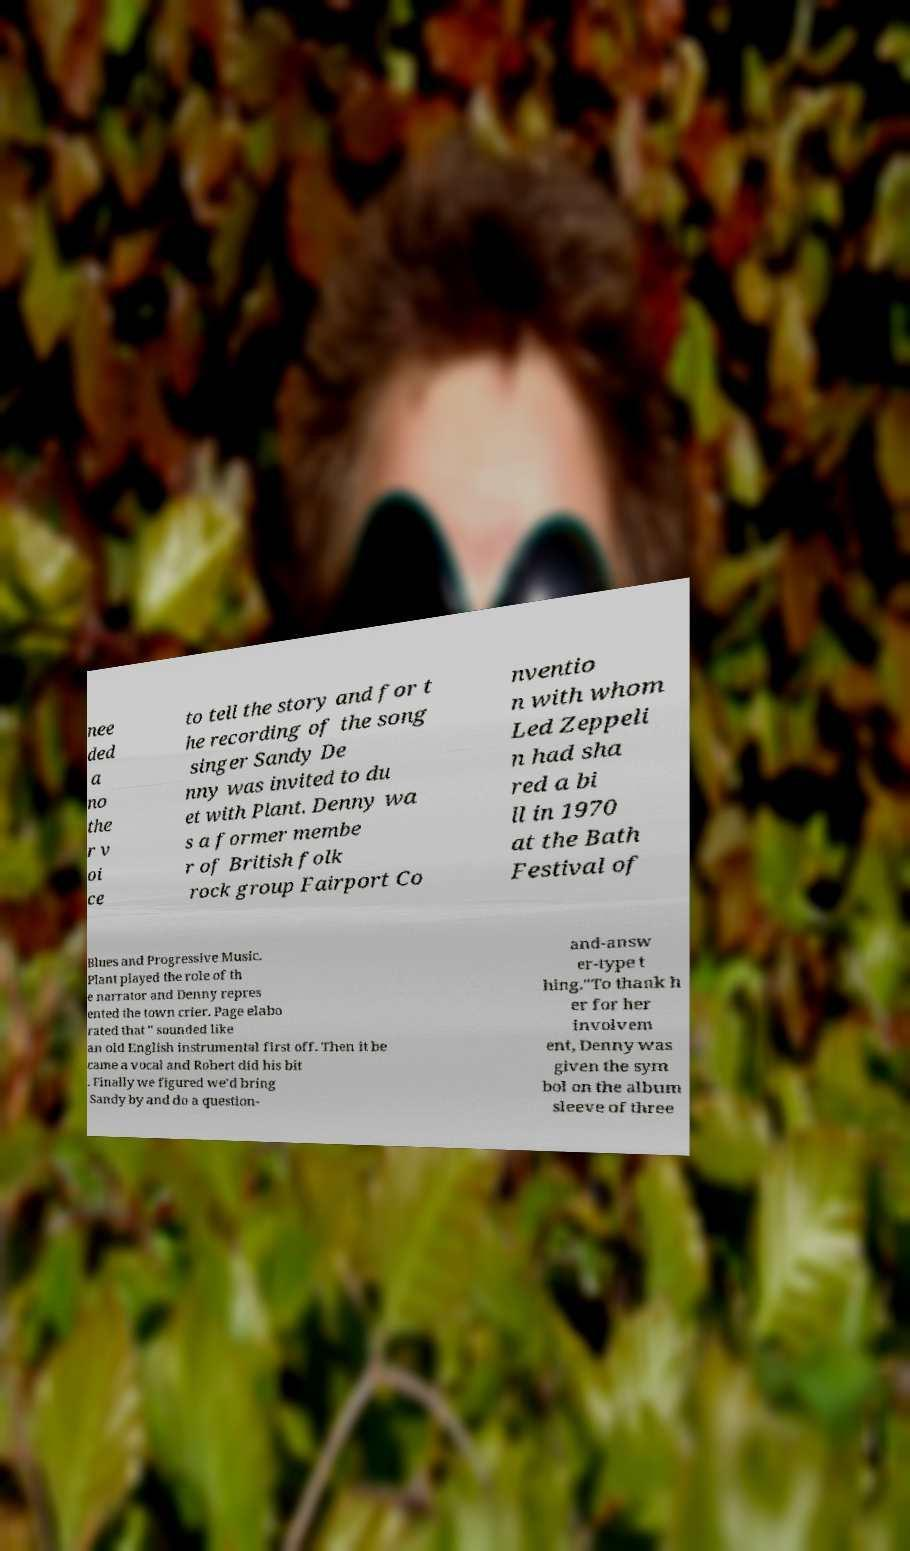There's text embedded in this image that I need extracted. Can you transcribe it verbatim? nee ded a no the r v oi ce to tell the story and for t he recording of the song singer Sandy De nny was invited to du et with Plant. Denny wa s a former membe r of British folk rock group Fairport Co nventio n with whom Led Zeppeli n had sha red a bi ll in 1970 at the Bath Festival of Blues and Progressive Music. Plant played the role of th e narrator and Denny repres ented the town crier. Page elabo rated that " sounded like an old English instrumental first off. Then it be came a vocal and Robert did his bit . Finally we figured we'd bring Sandy by and do a question- and-answ er-type t hing."To thank h er for her involvem ent, Denny was given the sym bol on the album sleeve of three 